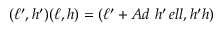Convert formula to latex. <formula><loc_0><loc_0><loc_500><loc_500>( \ell ^ { \prime } , h ^ { \prime } ) ( \ell , h ) = ( \ell ^ { \prime } + A d \ h ^ { \prime } \, e l l , h ^ { \prime } h )</formula> 